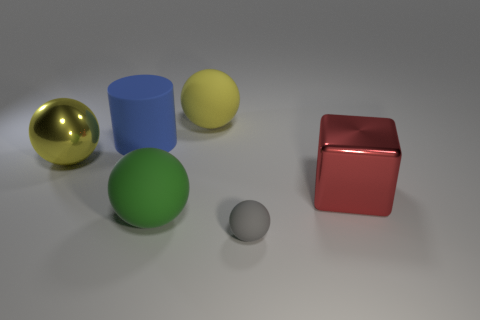How many yellow spheres must be subtracted to get 1 yellow spheres? 1 Subtract all large balls. How many balls are left? 1 Subtract all gray spheres. How many spheres are left? 3 Subtract 0 brown spheres. How many objects are left? 6 Subtract all cubes. How many objects are left? 5 Subtract 3 balls. How many balls are left? 1 Subtract all green balls. Subtract all green cubes. How many balls are left? 3 Subtract all blue cylinders. How many green spheres are left? 1 Subtract all large cylinders. Subtract all gray balls. How many objects are left? 4 Add 1 big shiny balls. How many big shiny balls are left? 2 